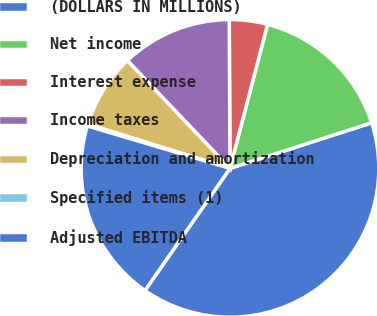<chart> <loc_0><loc_0><loc_500><loc_500><pie_chart><fcel>(DOLLARS IN MILLIONS)<fcel>Net income<fcel>Interest expense<fcel>Income taxes<fcel>Depreciation and amortization<fcel>Specified items (1)<fcel>Adjusted EBITDA<nl><fcel>39.64%<fcel>15.98%<fcel>4.14%<fcel>12.03%<fcel>8.09%<fcel>0.2%<fcel>19.92%<nl></chart> 